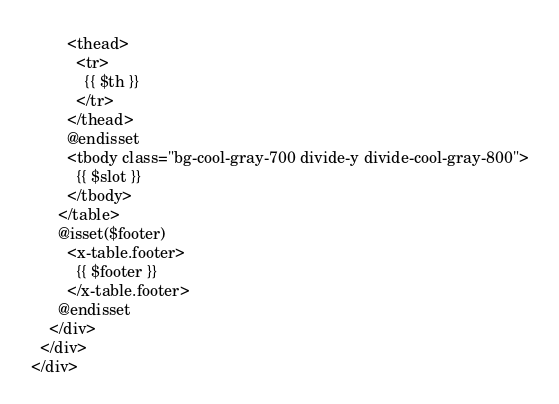Convert code to text. <code><loc_0><loc_0><loc_500><loc_500><_PHP_>        <thead>
          <tr>
            {{ $th }}
          </tr>
        </thead>
        @endisset
        <tbody class="bg-cool-gray-700 divide-y divide-cool-gray-800">
          {{ $slot }}
        </tbody>
      </table>
      @isset($footer)
        <x-table.footer>
          {{ $footer }}
        </x-table.footer>
      @endisset
    </div>
  </div>
</div>
</code> 